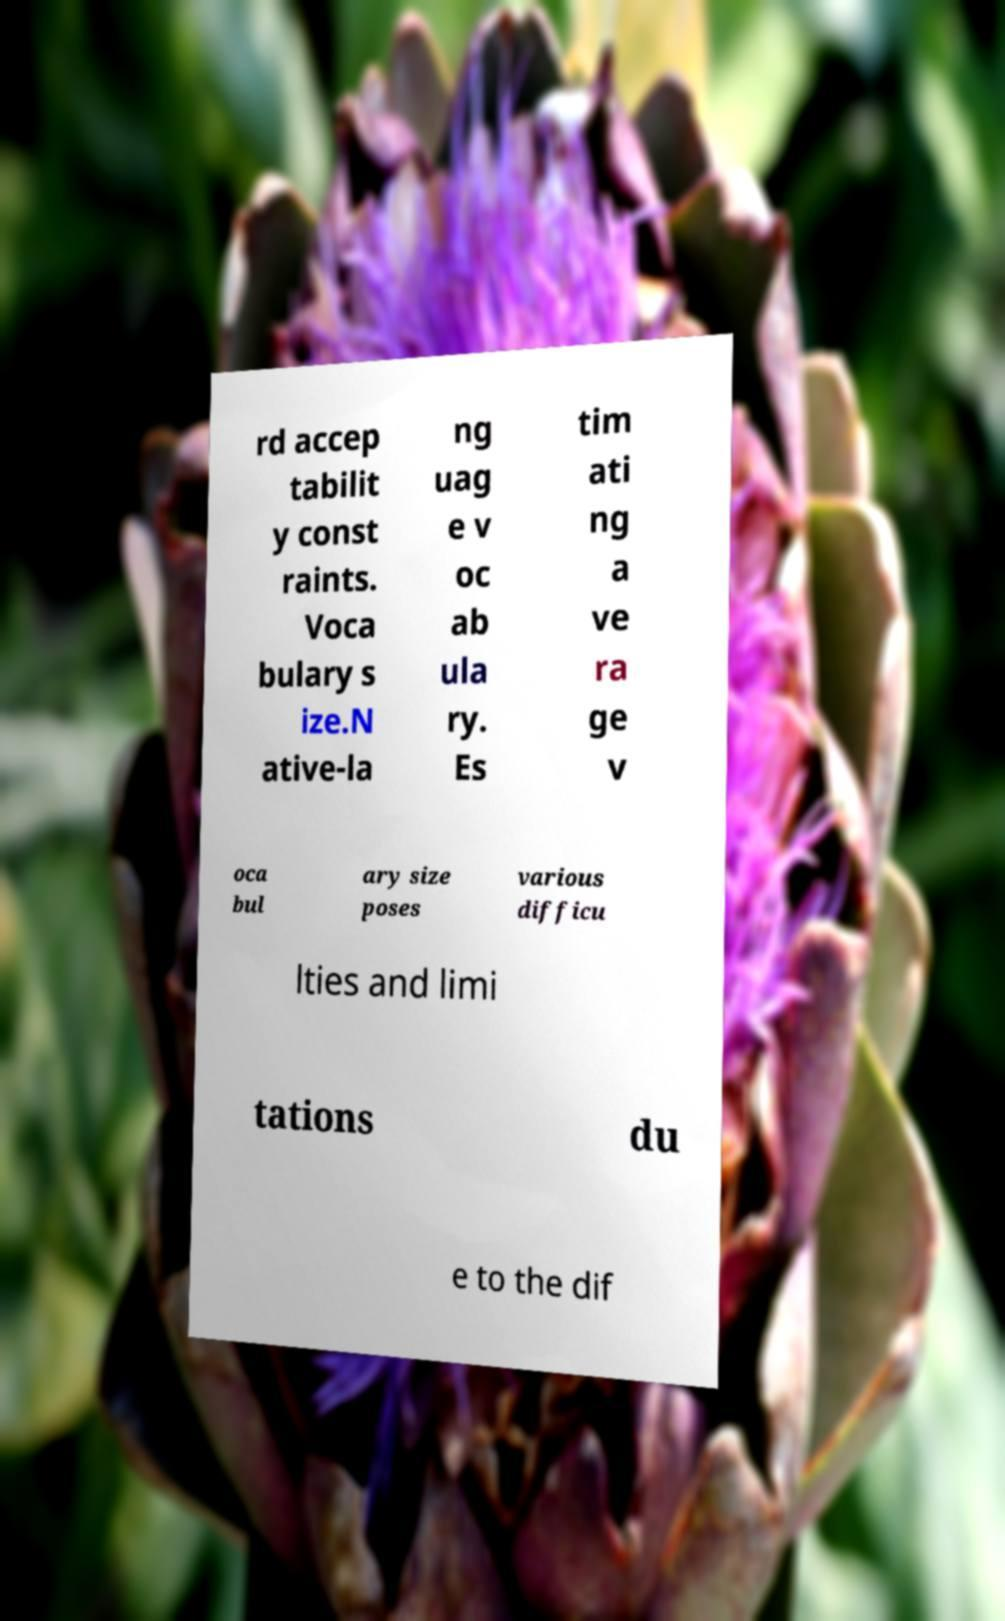There's text embedded in this image that I need extracted. Can you transcribe it verbatim? rd accep tabilit y const raints. Voca bulary s ize.N ative-la ng uag e v oc ab ula ry. Es tim ati ng a ve ra ge v oca bul ary size poses various difficu lties and limi tations du e to the dif 